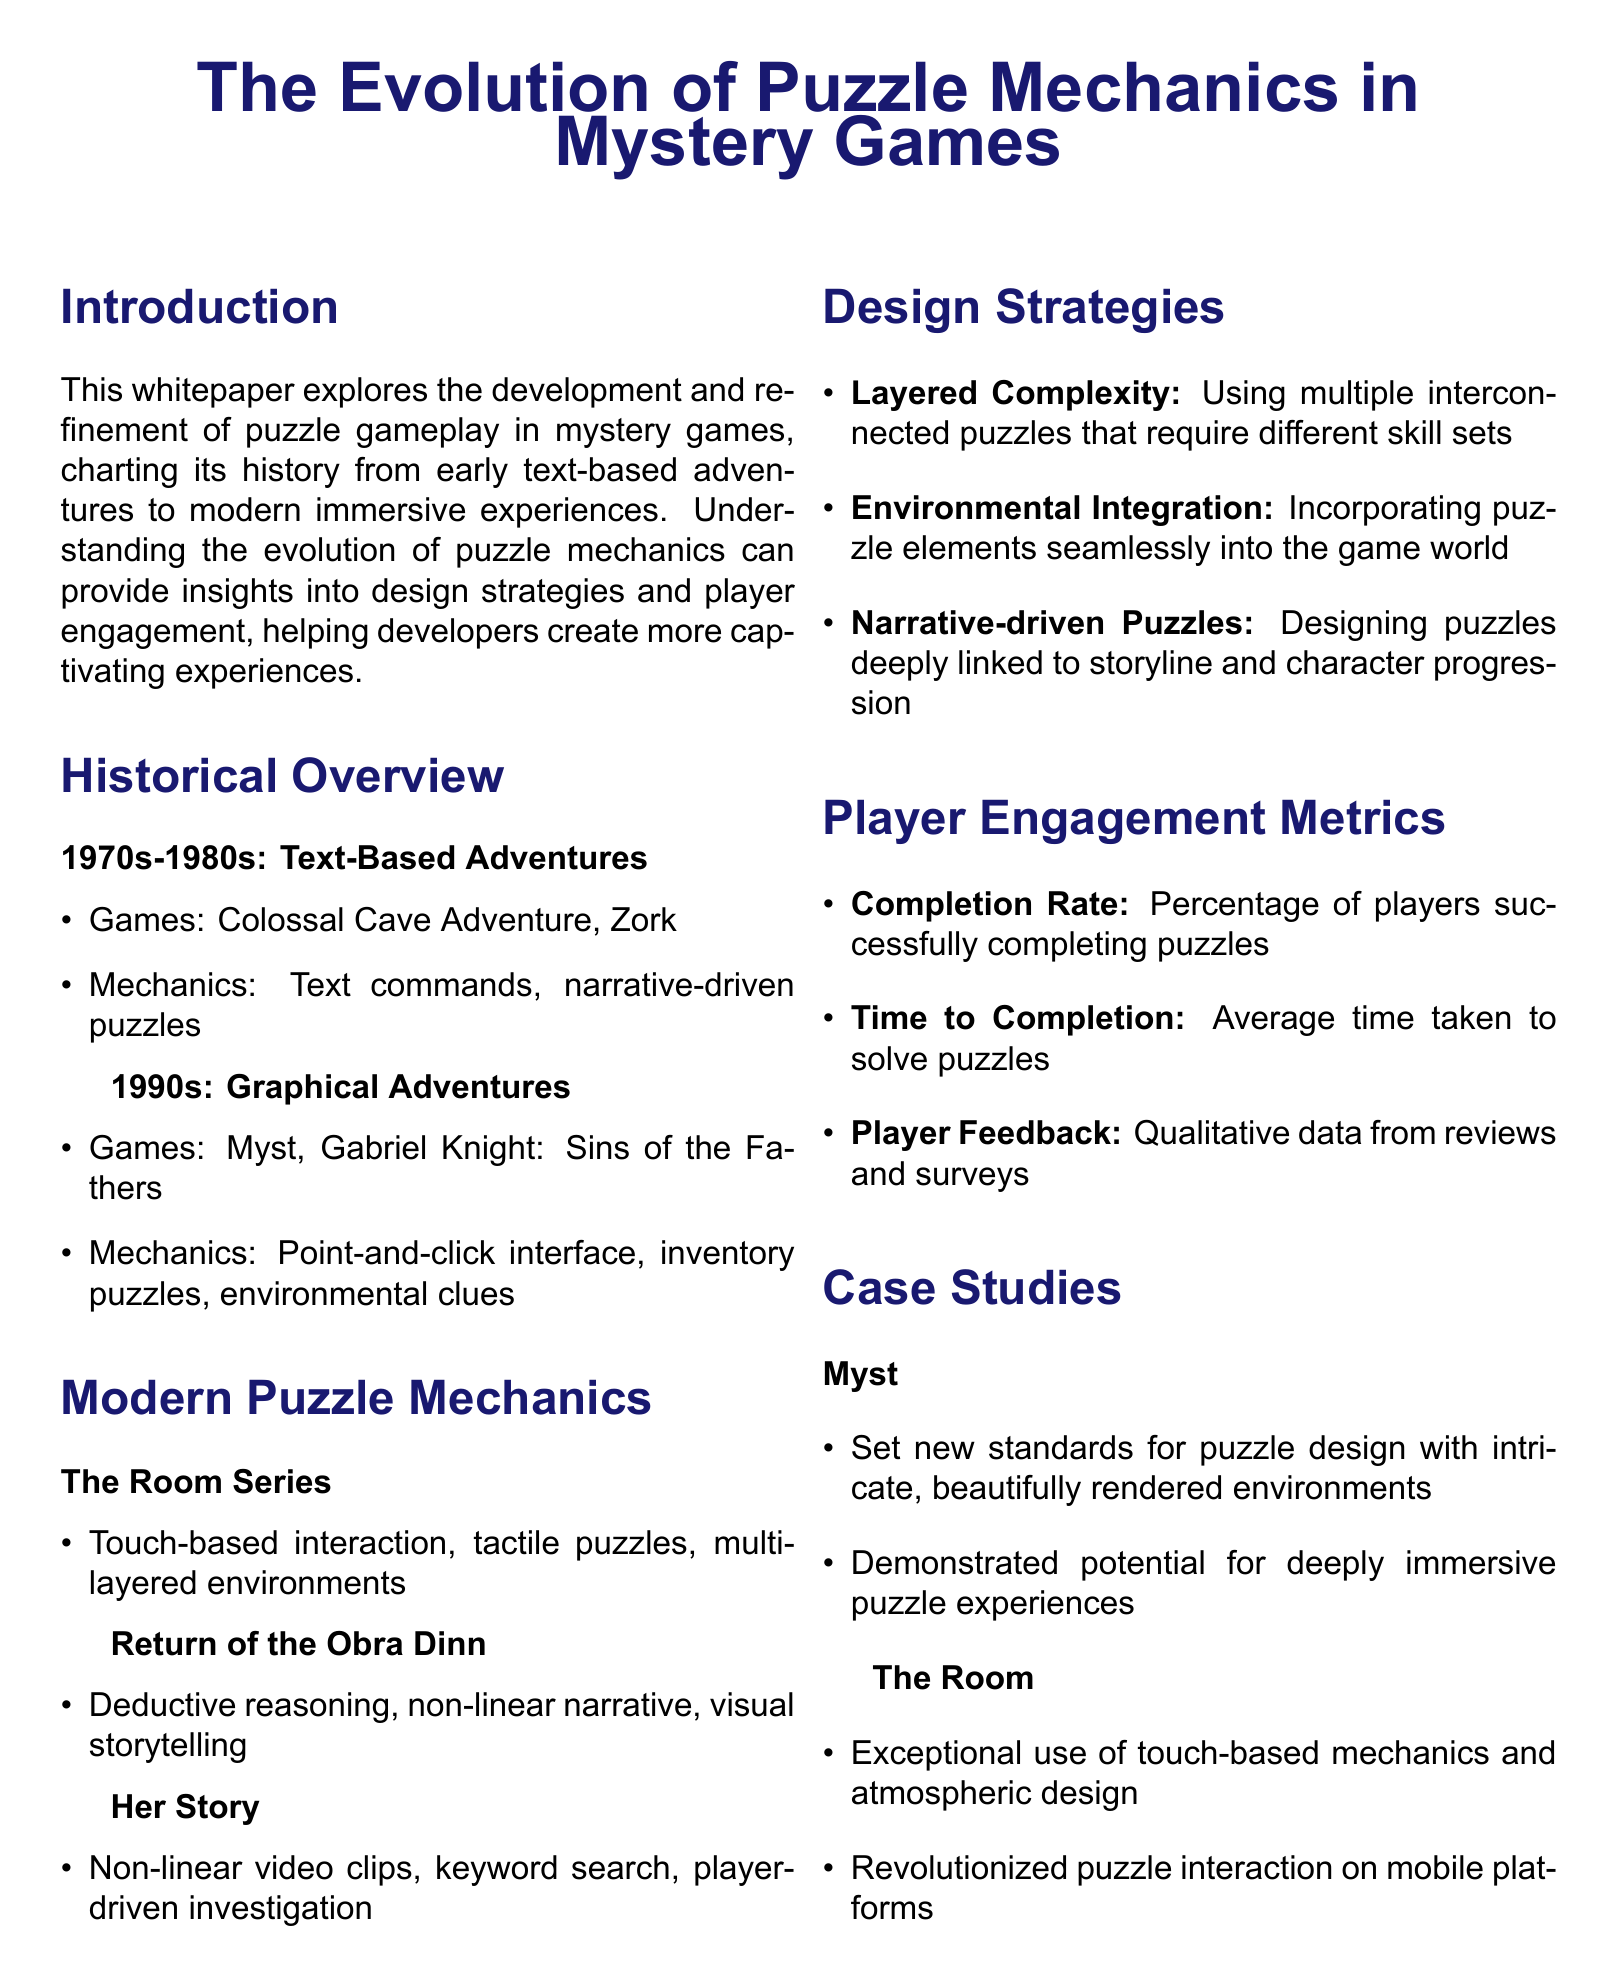What are the two main periods discussed in the historical overview? The document outlines the evolution of puzzle mechanics from text-based adventures in the 1970s-1980s to graphical adventures in the 1990s.
Answer: Text-Based Adventures and Graphical Adventures Which game is mentioned as part of the 1990s graphical adventures? The document lists Myst as one of the prominent games during the 1990s.
Answer: Myst What design strategy is highlighted for creating engaging puzzle experiences? Layered Complexity is emphasized as a design strategy utilizing interconnected puzzles requiring different skill sets.
Answer: Layered Complexity What player engagement metric is measured by the average time taken to solve puzzles? The document specifies Time to Completion as a metric related to player engagement.
Answer: Time to Completion In which case study was the achievement of new standards for puzzle design noted? Myst is cited as the case study that set new standards for puzzle design.
Answer: Myst What type of interaction does The Room Series excel in? The Room Series is noted for exceptional touch-based interaction in the document.
Answer: Touch-based interaction Which game uses keyword searches as part of its puzzle mechanics? The document identifies Her Story as the game utilizing keyword searches for investigation.
Answer: Her Story 